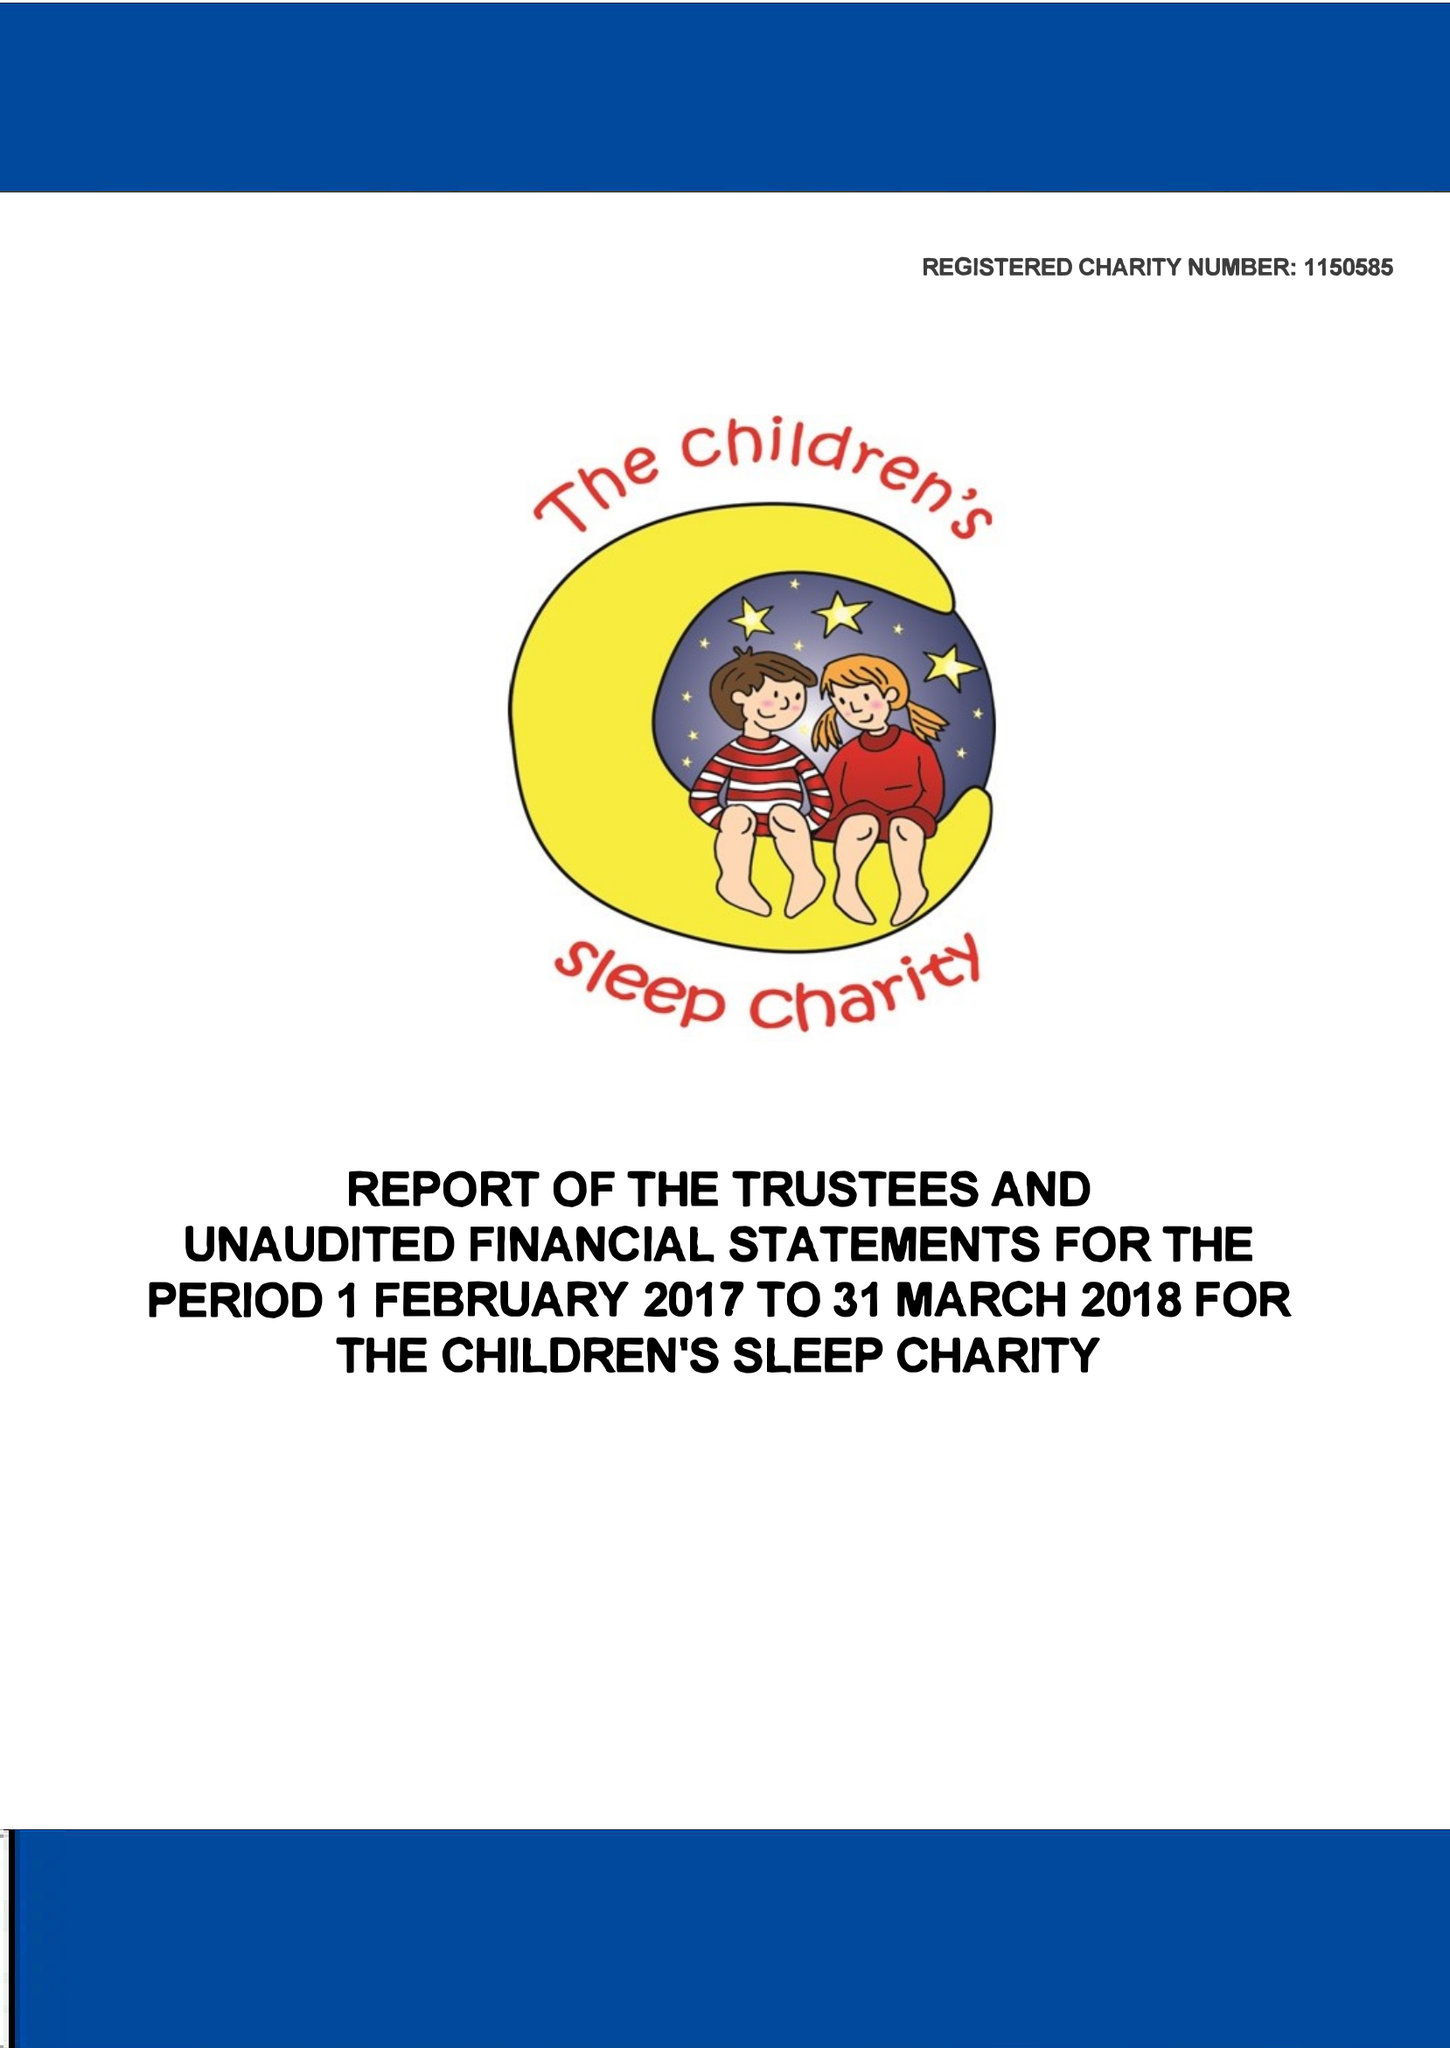What is the value for the income_annually_in_british_pounds?
Answer the question using a single word or phrase. 338140.00 